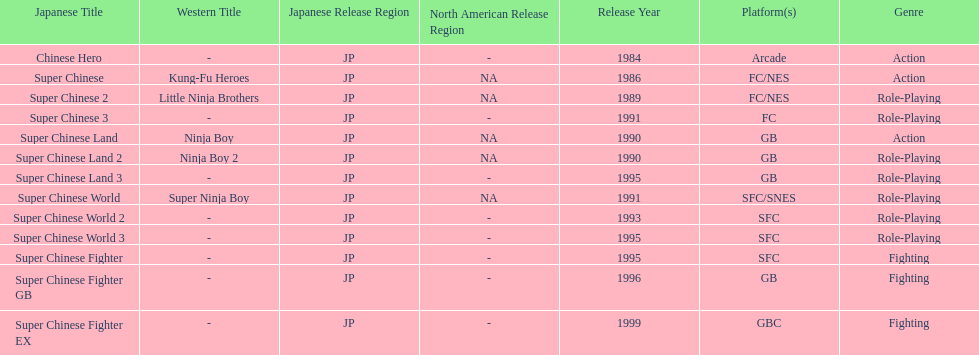Which platforms had the most titles released? GB. 